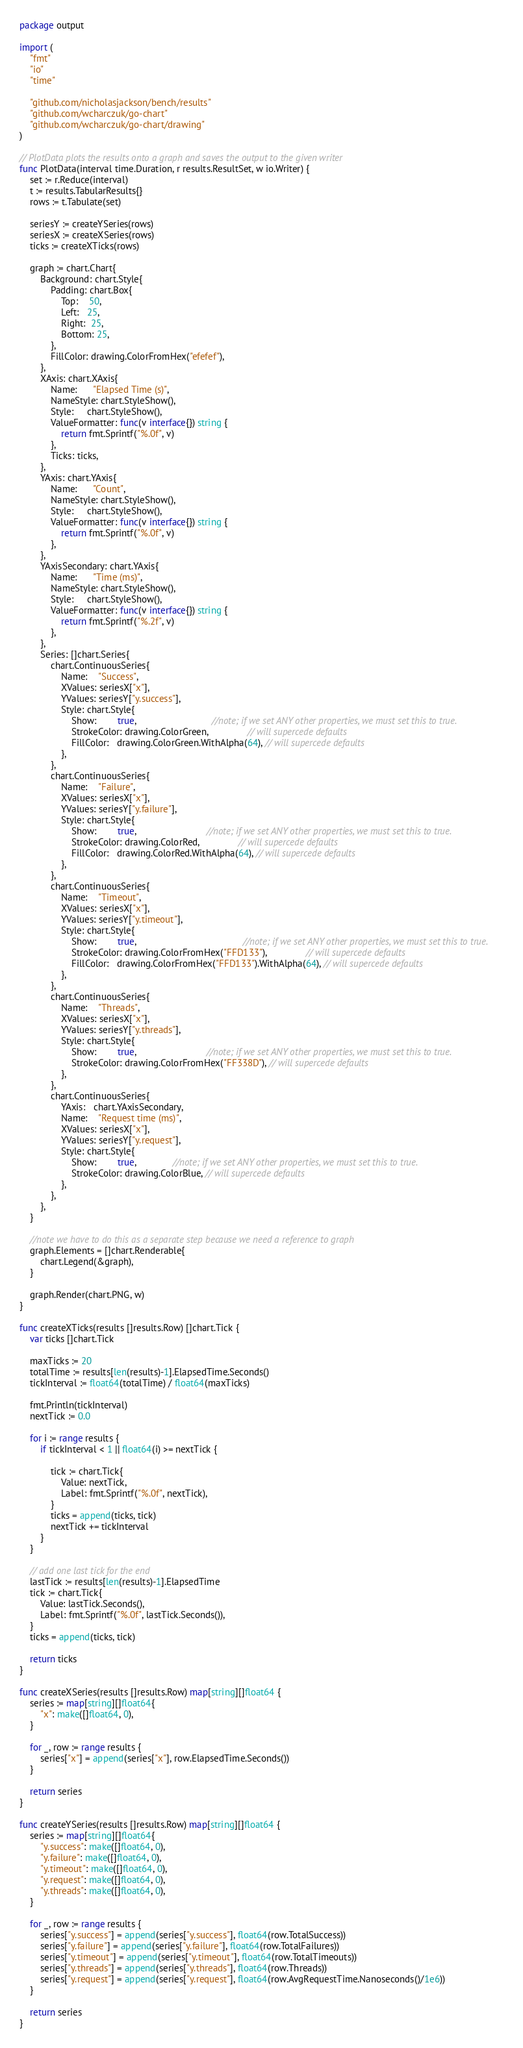<code> <loc_0><loc_0><loc_500><loc_500><_Go_>package output

import (
	"fmt"
	"io"
	"time"

	"github.com/nicholasjackson/bench/results"
	"github.com/wcharczuk/go-chart"
	"github.com/wcharczuk/go-chart/drawing"
)

// PlotData plots the results onto a graph and saves the output to the given writer
func PlotData(interval time.Duration, r results.ResultSet, w io.Writer) {
	set := r.Reduce(interval)
	t := results.TabularResults{}
	rows := t.Tabulate(set)

	seriesY := createYSeries(rows)
	seriesX := createXSeries(rows)
	ticks := createXTicks(rows)

	graph := chart.Chart{
		Background: chart.Style{
			Padding: chart.Box{
				Top:    50,
				Left:   25,
				Right:  25,
				Bottom: 25,
			},
			FillColor: drawing.ColorFromHex("efefef"),
		},
		XAxis: chart.XAxis{
			Name:      "Elapsed Time (s)",
			NameStyle: chart.StyleShow(),
			Style:     chart.StyleShow(),
			ValueFormatter: func(v interface{}) string {
				return fmt.Sprintf("%.0f", v)
			},
			Ticks: ticks,
		},
		YAxis: chart.YAxis{
			Name:      "Count",
			NameStyle: chart.StyleShow(),
			Style:     chart.StyleShow(),
			ValueFormatter: func(v interface{}) string {
				return fmt.Sprintf("%.0f", v)
			},
		},
		YAxisSecondary: chart.YAxis{
			Name:      "Time (ms)",
			NameStyle: chart.StyleShow(),
			Style:     chart.StyleShow(),
			ValueFormatter: func(v interface{}) string {
				return fmt.Sprintf("%.2f", v)
			},
		},
		Series: []chart.Series{
			chart.ContinuousSeries{
				Name:    "Success",
				XValues: seriesX["x"],
				YValues: seriesY["y.success"],
				Style: chart.Style{
					Show:        true,                             //note; if we set ANY other properties, we must set this to true.
					StrokeColor: drawing.ColorGreen,               // will supercede defaults
					FillColor:   drawing.ColorGreen.WithAlpha(64), // will supercede defaults
				},
			},
			chart.ContinuousSeries{
				Name:    "Failure",
				XValues: seriesX["x"],
				YValues: seriesY["y.failure"],
				Style: chart.Style{
					Show:        true,                           //note; if we set ANY other properties, we must set this to true.
					StrokeColor: drawing.ColorRed,               // will supercede defaults
					FillColor:   drawing.ColorRed.WithAlpha(64), // will supercede defaults
				},
			},
			chart.ContinuousSeries{
				Name:    "Timeout",
				XValues: seriesX["x"],
				YValues: seriesY["y.timeout"],
				Style: chart.Style{
					Show:        true,                                         //note; if we set ANY other properties, we must set this to true.
					StrokeColor: drawing.ColorFromHex("FFD133"),               // will supercede defaults
					FillColor:   drawing.ColorFromHex("FFD133").WithAlpha(64), // will supercede defaults
				},
			},
			chart.ContinuousSeries{
				Name:    "Threads",
				XValues: seriesX["x"],
				YValues: seriesY["y.threads"],
				Style: chart.Style{
					Show:        true,                           //note; if we set ANY other properties, we must set this to true.
					StrokeColor: drawing.ColorFromHex("FF338D"), // will supercede defaults
				},
			},
			chart.ContinuousSeries{
				YAxis:   chart.YAxisSecondary,
				Name:    "Request time (ms)",
				XValues: seriesX["x"],
				YValues: seriesY["y.request"],
				Style: chart.Style{
					Show:        true,              //note; if we set ANY other properties, we must set this to true.
					StrokeColor: drawing.ColorBlue, // will supercede defaults
				},
			},
		},
	}

	//note we have to do this as a separate step because we need a reference to graph
	graph.Elements = []chart.Renderable{
		chart.Legend(&graph),
	}

	graph.Render(chart.PNG, w)
}

func createXTicks(results []results.Row) []chart.Tick {
	var ticks []chart.Tick

	maxTicks := 20
	totalTime := results[len(results)-1].ElapsedTime.Seconds()
	tickInterval := float64(totalTime) / float64(maxTicks)

	fmt.Println(tickInterval)
	nextTick := 0.0

	for i := range results {
		if tickInterval < 1 || float64(i) >= nextTick {

			tick := chart.Tick{
				Value: nextTick,
				Label: fmt.Sprintf("%.0f", nextTick),
			}
			ticks = append(ticks, tick)
			nextTick += tickInterval
		}
	}

	// add one last tick for the end
	lastTick := results[len(results)-1].ElapsedTime
	tick := chart.Tick{
		Value: lastTick.Seconds(),
		Label: fmt.Sprintf("%.0f", lastTick.Seconds()),
	}
	ticks = append(ticks, tick)

	return ticks
}

func createXSeries(results []results.Row) map[string][]float64 {
	series := map[string][]float64{
		"x": make([]float64, 0),
	}

	for _, row := range results {
		series["x"] = append(series["x"], row.ElapsedTime.Seconds())
	}

	return series
}

func createYSeries(results []results.Row) map[string][]float64 {
	series := map[string][]float64{
		"y.success": make([]float64, 0),
		"y.failure": make([]float64, 0),
		"y.timeout": make([]float64, 0),
		"y.request": make([]float64, 0),
		"y.threads": make([]float64, 0),
	}

	for _, row := range results {
		series["y.success"] = append(series["y.success"], float64(row.TotalSuccess))
		series["y.failure"] = append(series["y.failure"], float64(row.TotalFailures))
		series["y.timeout"] = append(series["y.timeout"], float64(row.TotalTimeouts))
		series["y.threads"] = append(series["y.threads"], float64(row.Threads))
		series["y.request"] = append(series["y.request"], float64(row.AvgRequestTime.Nanoseconds()/1e6))
	}

	return series
}
</code> 